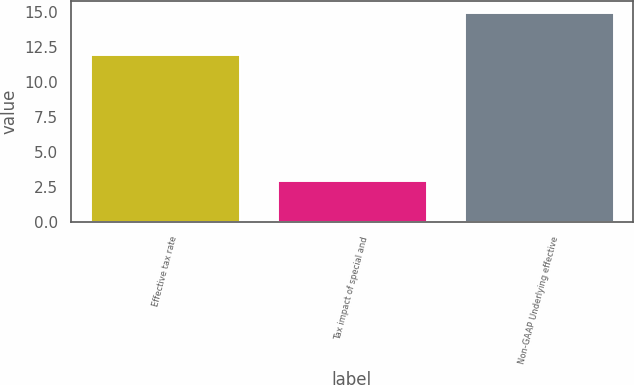Convert chart to OTSL. <chart><loc_0><loc_0><loc_500><loc_500><bar_chart><fcel>Effective tax rate<fcel>Tax impact of special and<fcel>Non-GAAP Underlying effective<nl><fcel>12<fcel>3<fcel>15<nl></chart> 